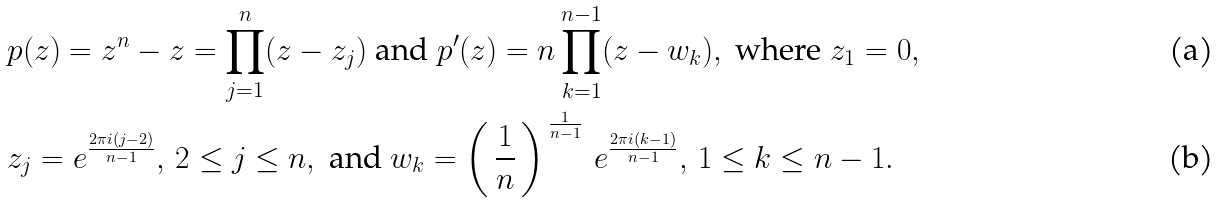Convert formula to latex. <formula><loc_0><loc_0><loc_500><loc_500>& p ( z ) = z ^ { n } - z = \prod _ { j = 1 } ^ { n } ( z - z _ { j } ) \text { and } p ^ { \prime } ( z ) = n \prod _ { k = 1 } ^ { n - 1 } ( z - w _ { k } ) , \text { where } z _ { 1 } = 0 , \\ & z _ { j } = e ^ { \frac { 2 \pi i ( j - 2 ) } { n - 1 } } , \, 2 \leq j \leq n , \text { and } w _ { k } = \left ( \, \frac { 1 } { n } \, \right ) ^ { \, \frac { 1 } { n - 1 } } \, e ^ { \frac { 2 \pi i ( k - 1 ) } { n - 1 } } , \, 1 \leq k \leq n - 1 .</formula> 